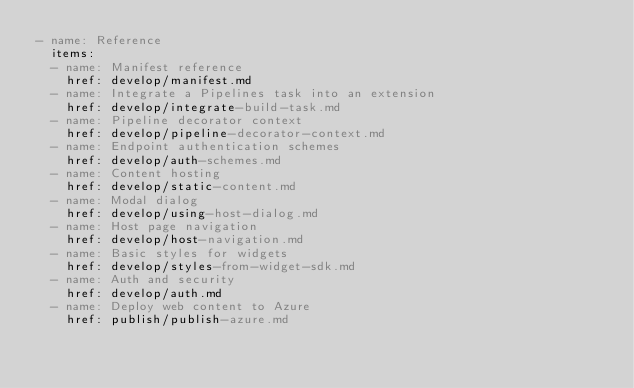Convert code to text. <code><loc_0><loc_0><loc_500><loc_500><_YAML_>- name: Reference
  items:
  - name: Manifest reference
    href: develop/manifest.md
  - name: Integrate a Pipelines task into an extension
    href: develop/integrate-build-task.md
  - name: Pipeline decorator context
    href: develop/pipeline-decorator-context.md
  - name: Endpoint authentication schemes
    href: develop/auth-schemes.md
  - name: Content hosting
    href: develop/static-content.md
  - name: Modal dialog
    href: develop/using-host-dialog.md
  - name: Host page navigation
    href: develop/host-navigation.md
  - name: Basic styles for widgets
    href: develop/styles-from-widget-sdk.md
  - name: Auth and security
    href: develop/auth.md
  - name: Deploy web content to Azure
    href: publish/publish-azure.md</code> 